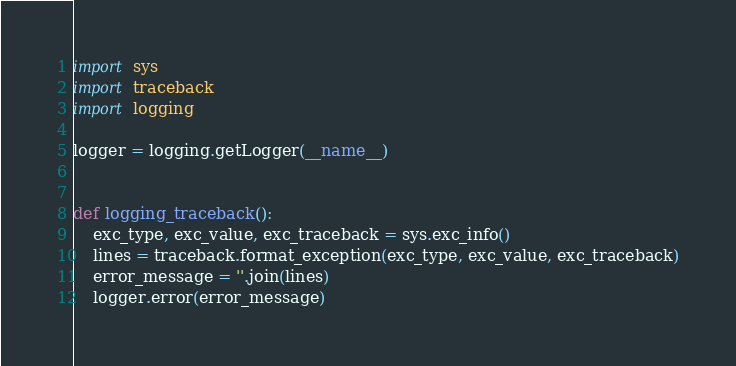Convert code to text. <code><loc_0><loc_0><loc_500><loc_500><_Python_>import sys
import traceback
import logging

logger = logging.getLogger(__name__)


def logging_traceback():
    exc_type, exc_value, exc_traceback = sys.exc_info()
    lines = traceback.format_exception(exc_type, exc_value, exc_traceback)
    error_message = ''.join(lines)
    logger.error(error_message)
</code> 